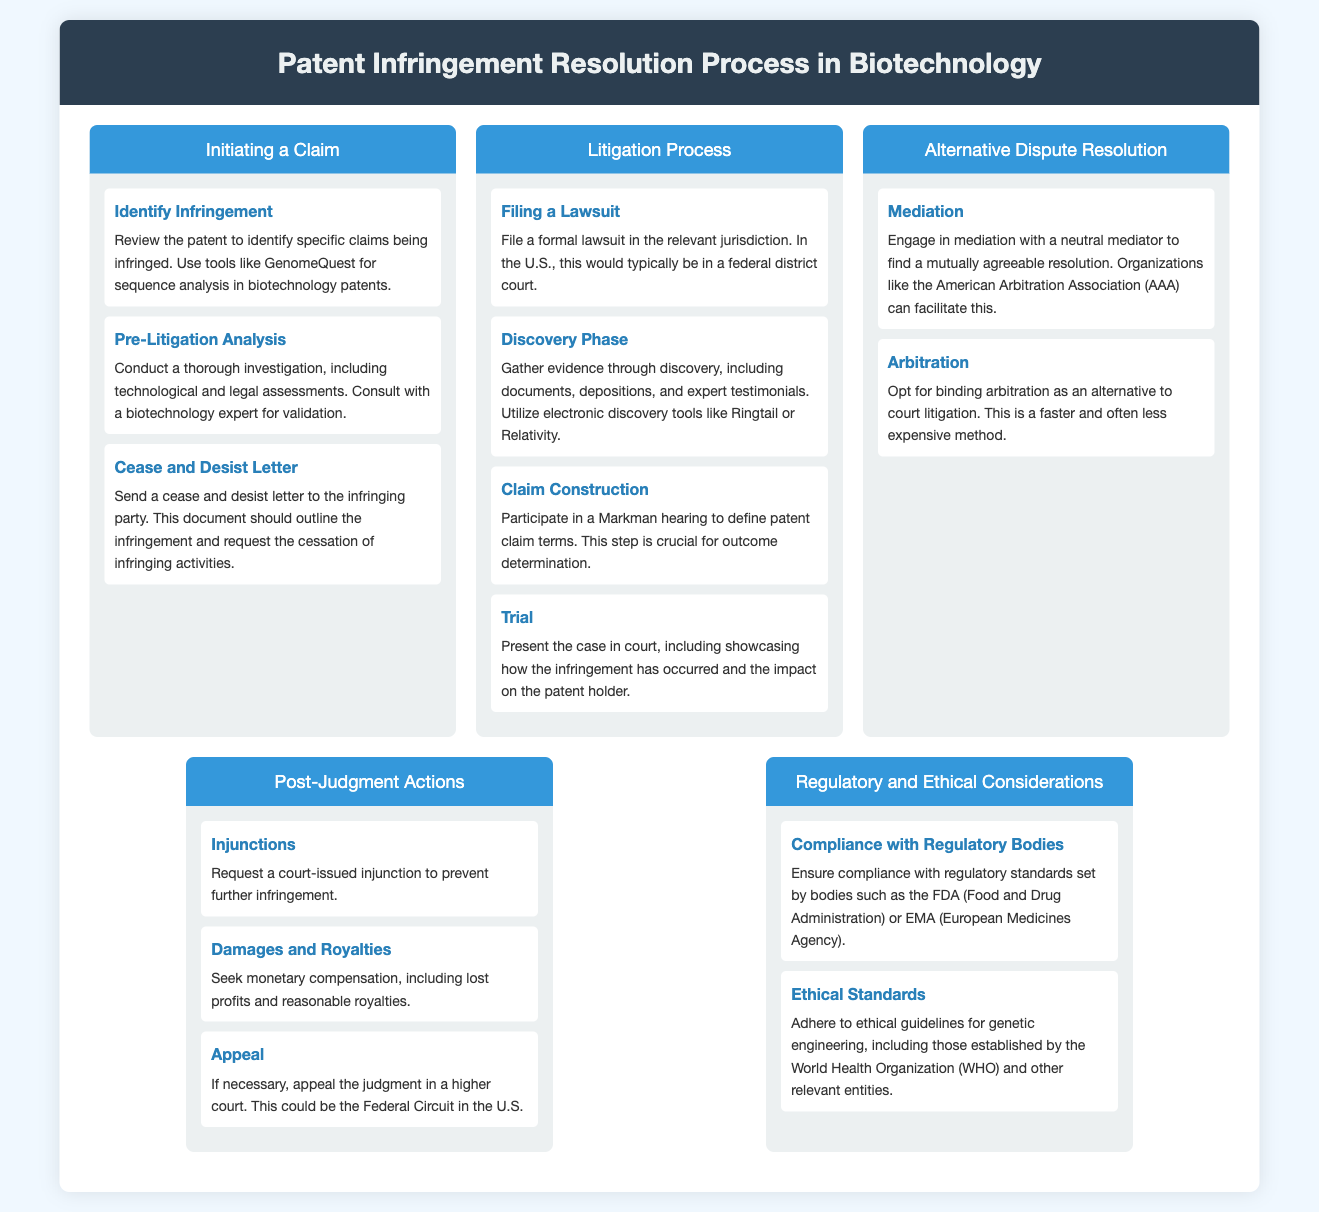what is the first step in initiating a claim? The first step listed in the process of initiating a claim is to identify the infringement.
Answer: Identify Infringement what is the purpose of a cease and desist letter? A cease and desist letter is used to request the cessation of infringing activities.
Answer: Request cessation of infringing activities which phase involves gathering evidence? The phase where evidence is gathered is the Discovery Phase.
Answer: Discovery Phase what is a Markman hearing? A Markman hearing is participated in for defining patent claim terms, crucial for outcome determination.
Answer: Define patent claim terms what is one alternative to court litigation? One alternative to court litigation mentioned is arbitration.
Answer: Arbitration which regulatory body is mentioned for compliance? The regulatory body mentioned for compliance is the FDA (Food and Drug Administration).
Answer: FDA what type of compensation can be sought post-judgment? Post-judgment compensation includes lost profits and reasonable royalties.
Answer: Lost profits and reasonable royalties what is the final action if necessary after a judgment? The final action that can be taken if necessary after a judgment is to appeal.
Answer: Appeal 